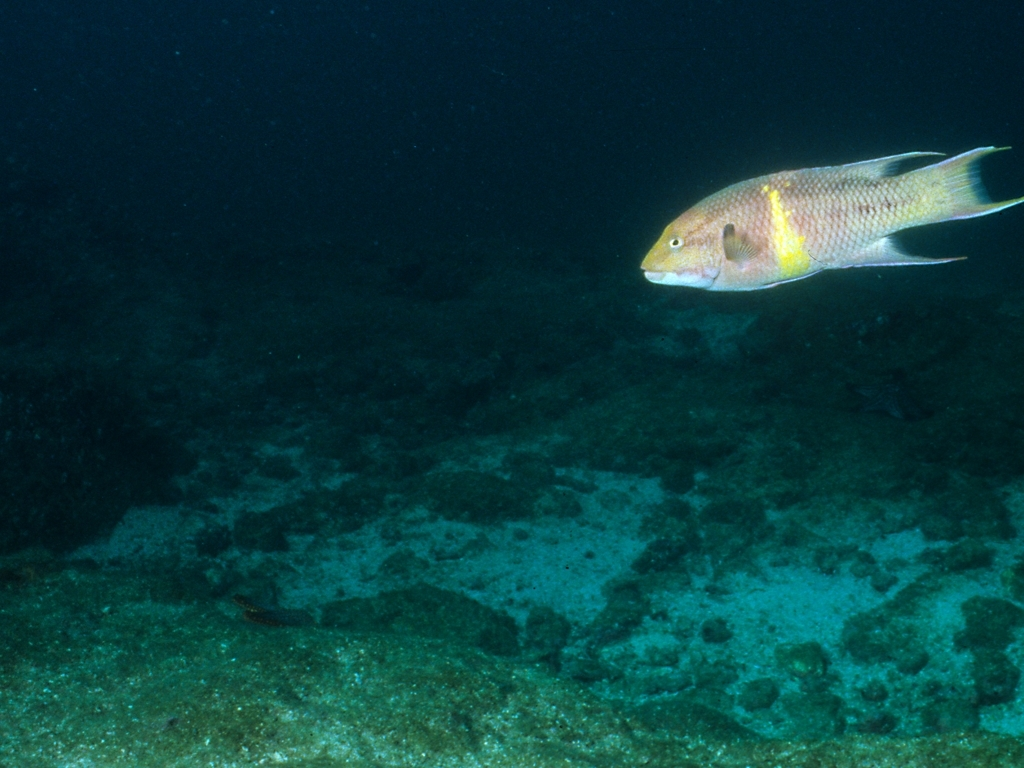Is the fish's texture retained? Yes, the fish's texture appears to be well-retained in this underwater photograph. One can observe the fine scales and gradations of color that range from a pale shade on the belly to darker hues along the back. A distinctive yellow to orange band can also be seen along the sides of the fish, adding a visual accent to its sleek body. 